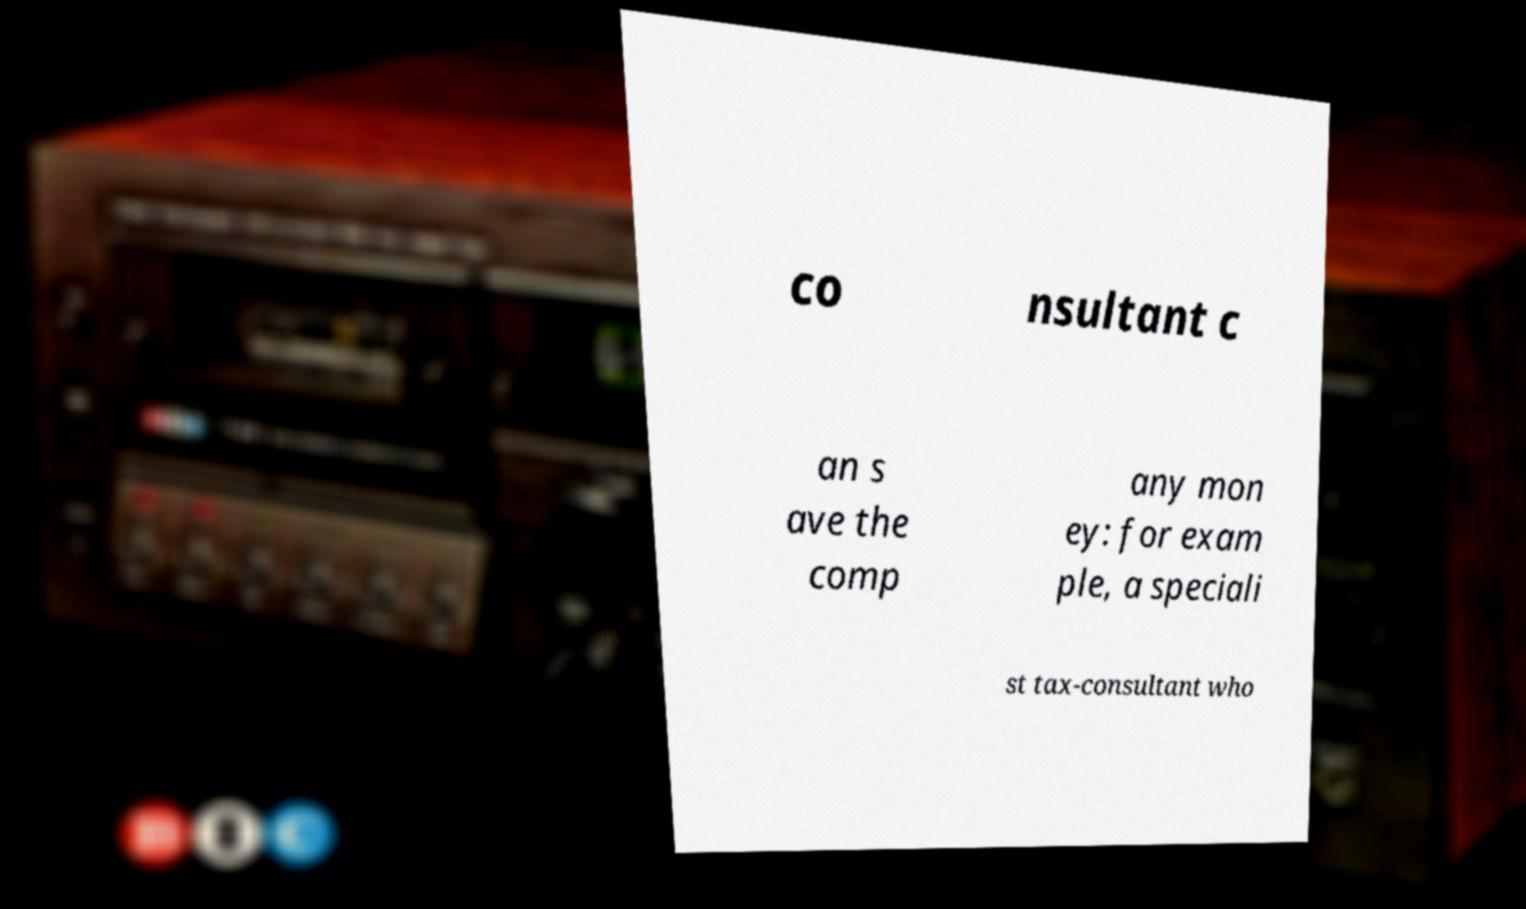For documentation purposes, I need the text within this image transcribed. Could you provide that? co nsultant c an s ave the comp any mon ey: for exam ple, a speciali st tax-consultant who 